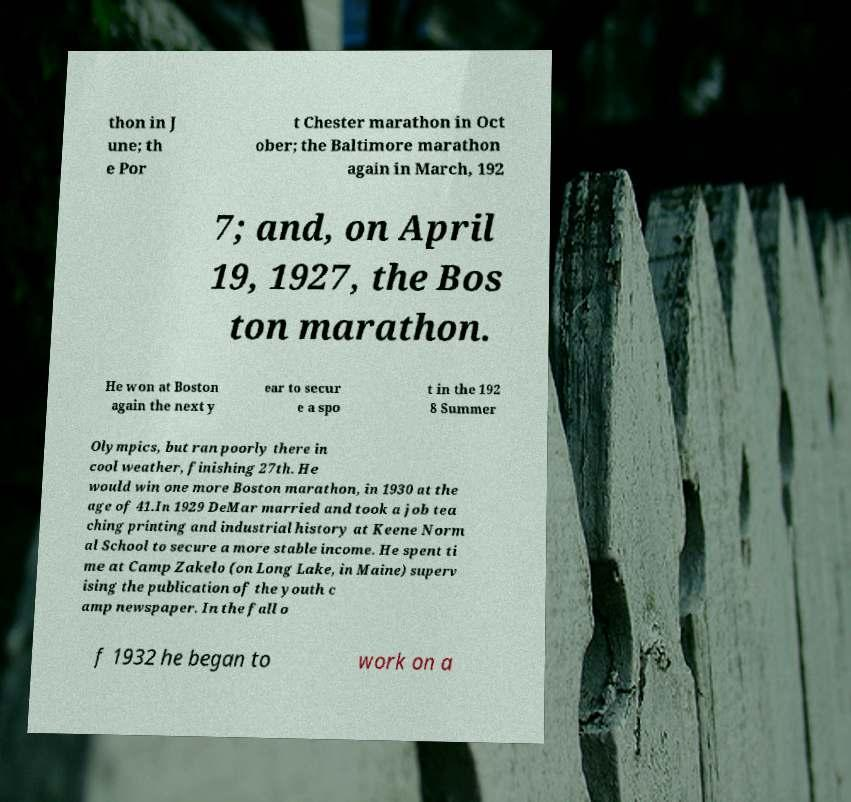For documentation purposes, I need the text within this image transcribed. Could you provide that? thon in J une; th e Por t Chester marathon in Oct ober; the Baltimore marathon again in March, 192 7; and, on April 19, 1927, the Bos ton marathon. He won at Boston again the next y ear to secur e a spo t in the 192 8 Summer Olympics, but ran poorly there in cool weather, finishing 27th. He would win one more Boston marathon, in 1930 at the age of 41.In 1929 DeMar married and took a job tea ching printing and industrial history at Keene Norm al School to secure a more stable income. He spent ti me at Camp Zakelo (on Long Lake, in Maine) superv ising the publication of the youth c amp newspaper. In the fall o f 1932 he began to work on a 